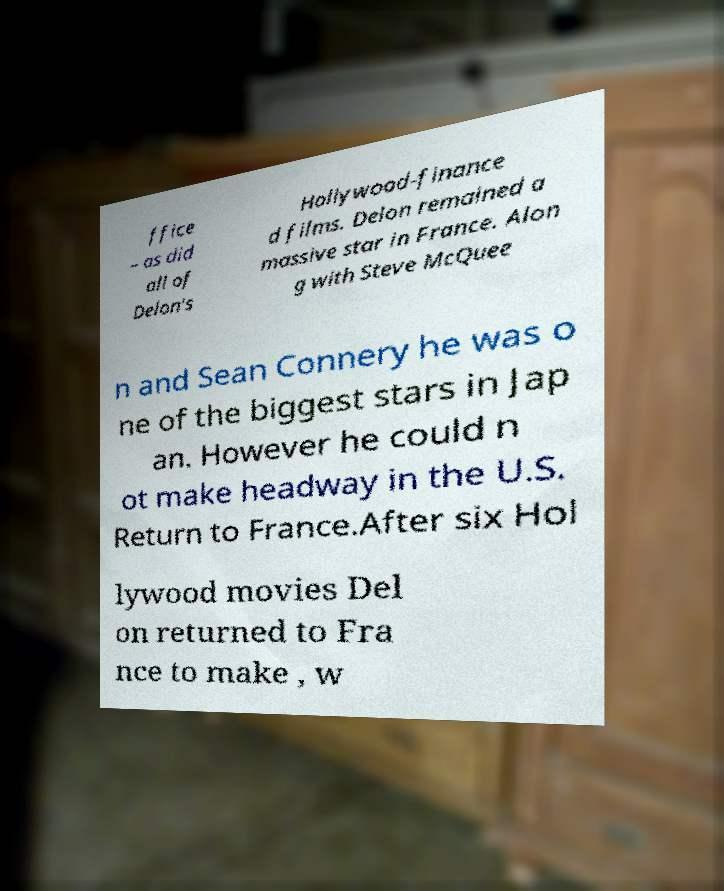Can you read and provide the text displayed in the image?This photo seems to have some interesting text. Can you extract and type it out for me? ffice – as did all of Delon's Hollywood-finance d films. Delon remained a massive star in France. Alon g with Steve McQuee n and Sean Connery he was o ne of the biggest stars in Jap an. However he could n ot make headway in the U.S. Return to France.After six Hol lywood movies Del on returned to Fra nce to make , w 